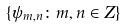Convert formula to latex. <formula><loc_0><loc_0><loc_500><loc_500>\{ \psi _ { m , n } \colon m , n \in Z \}</formula> 